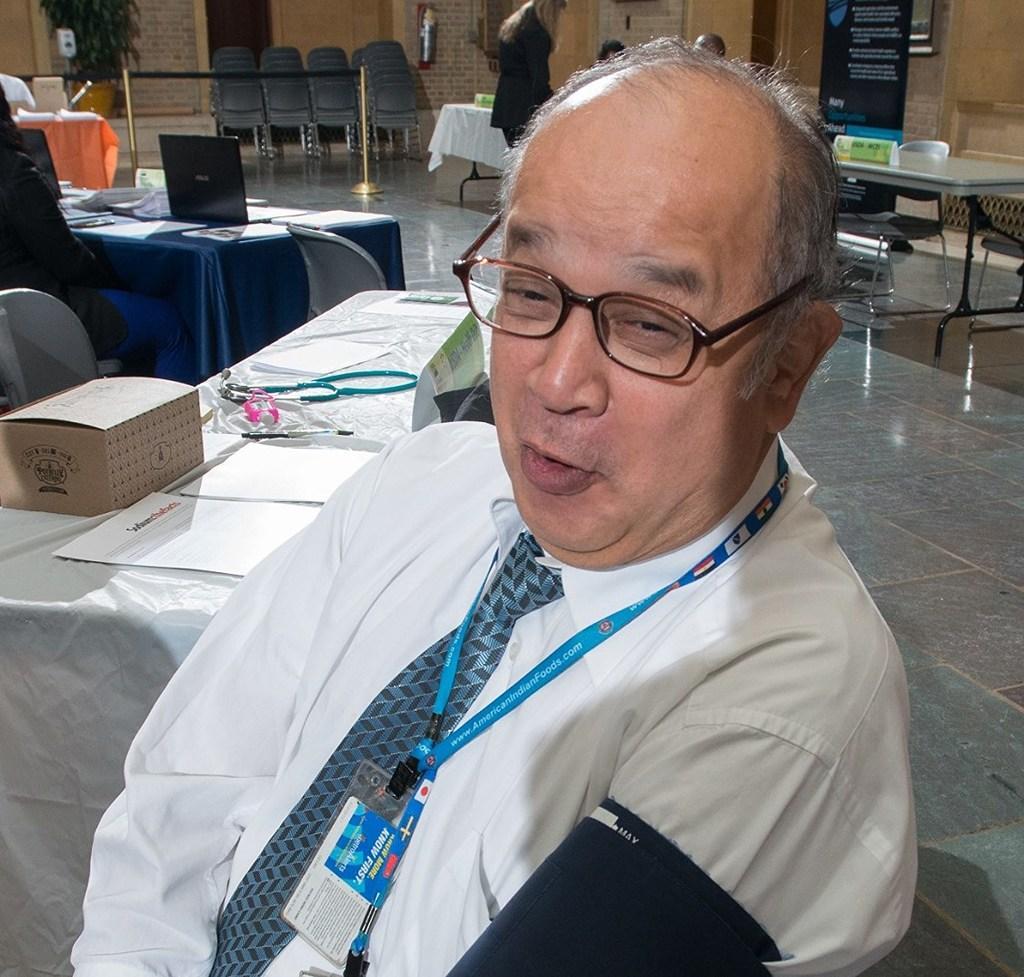How would you summarize this image in a sentence or two? In the center of the image we can see a man wearing glasses and also the identity card. Behind the man we can see a cardboard box, papers, pen and also some other objects on the table which is covered with the cover. Image also consists of papers, laptop, chairs, plant and also tables which are covered with the clothes. We can also see the floor. There is a banner with text. We can also see the wall, door and also the fence. 